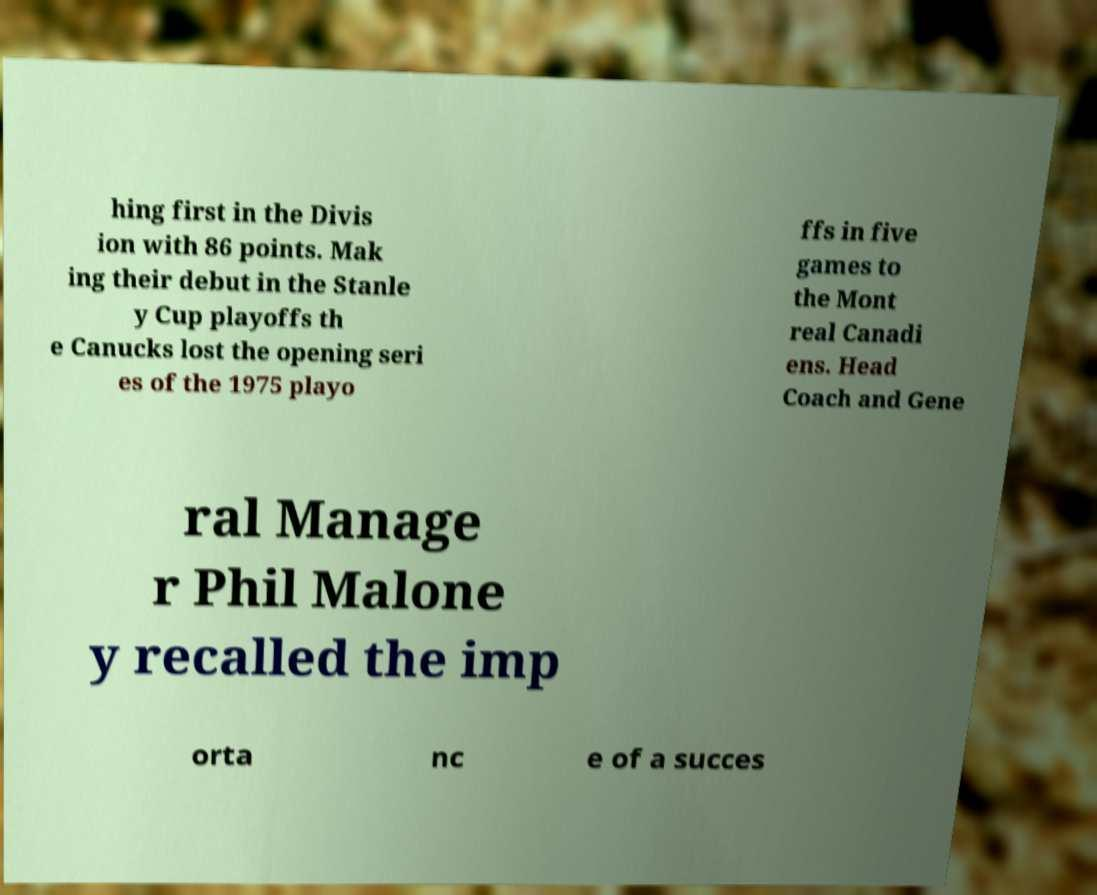Could you extract and type out the text from this image? hing first in the Divis ion with 86 points. Mak ing their debut in the Stanle y Cup playoffs th e Canucks lost the opening seri es of the 1975 playo ffs in five games to the Mont real Canadi ens. Head Coach and Gene ral Manage r Phil Malone y recalled the imp orta nc e of a succes 